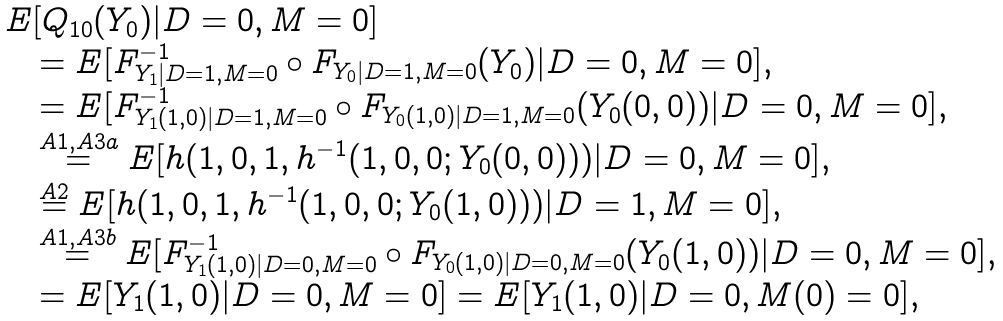<formula> <loc_0><loc_0><loc_500><loc_500>\begin{array} { r l } & E [ Q _ { 1 0 } ( Y _ { 0 } ) | D = 0 , M = 0 ] \\ & \quad = E [ F _ { Y _ { 1 } | D = 1 , M = 0 } ^ { - 1 } \circ F _ { Y _ { 0 } | D = 1 , M = 0 } ( Y _ { 0 } ) | D = 0 , M = 0 ] , \\ & \quad = E [ F _ { Y _ { 1 } ( 1 , 0 ) | D = 1 , M = 0 } ^ { - 1 } \circ F _ { Y _ { 0 } ( 1 , 0 ) | D = 1 , M = 0 } ( Y _ { 0 } ( 0 , 0 ) ) | D = 0 , M = 0 ] , \\ & \quad \stackrel { A 1 , A 3 a } { = } E [ h ( 1 , 0 , 1 , h ^ { - 1 } ( 1 , 0 , 0 ; Y _ { 0 } ( 0 , 0 ) ) ) | D = 0 , M = 0 ] , \\ & \quad \stackrel { A 2 } { = } E [ h ( 1 , 0 , 1 , h ^ { - 1 } ( 1 , 0 , 0 ; Y _ { 0 } ( 1 , 0 ) ) ) | D = 1 , M = 0 ] , \\ & \quad \stackrel { A 1 , A 3 b } { = } E [ F _ { Y _ { 1 } ( 1 , 0 ) | D = 0 , M = 0 } ^ { - 1 } \circ F _ { Y _ { 0 } ( 1 , 0 ) | D = 0 , M = 0 } ( Y _ { 0 } ( 1 , 0 ) ) | D = 0 , M = 0 ] , \\ & \quad = E [ Y _ { 1 } ( 1 , 0 ) | D = 0 , M = 0 ] = E [ Y _ { 1 } ( 1 , 0 ) | D = 0 , M ( 0 ) = 0 ] , \end{array}</formula> 